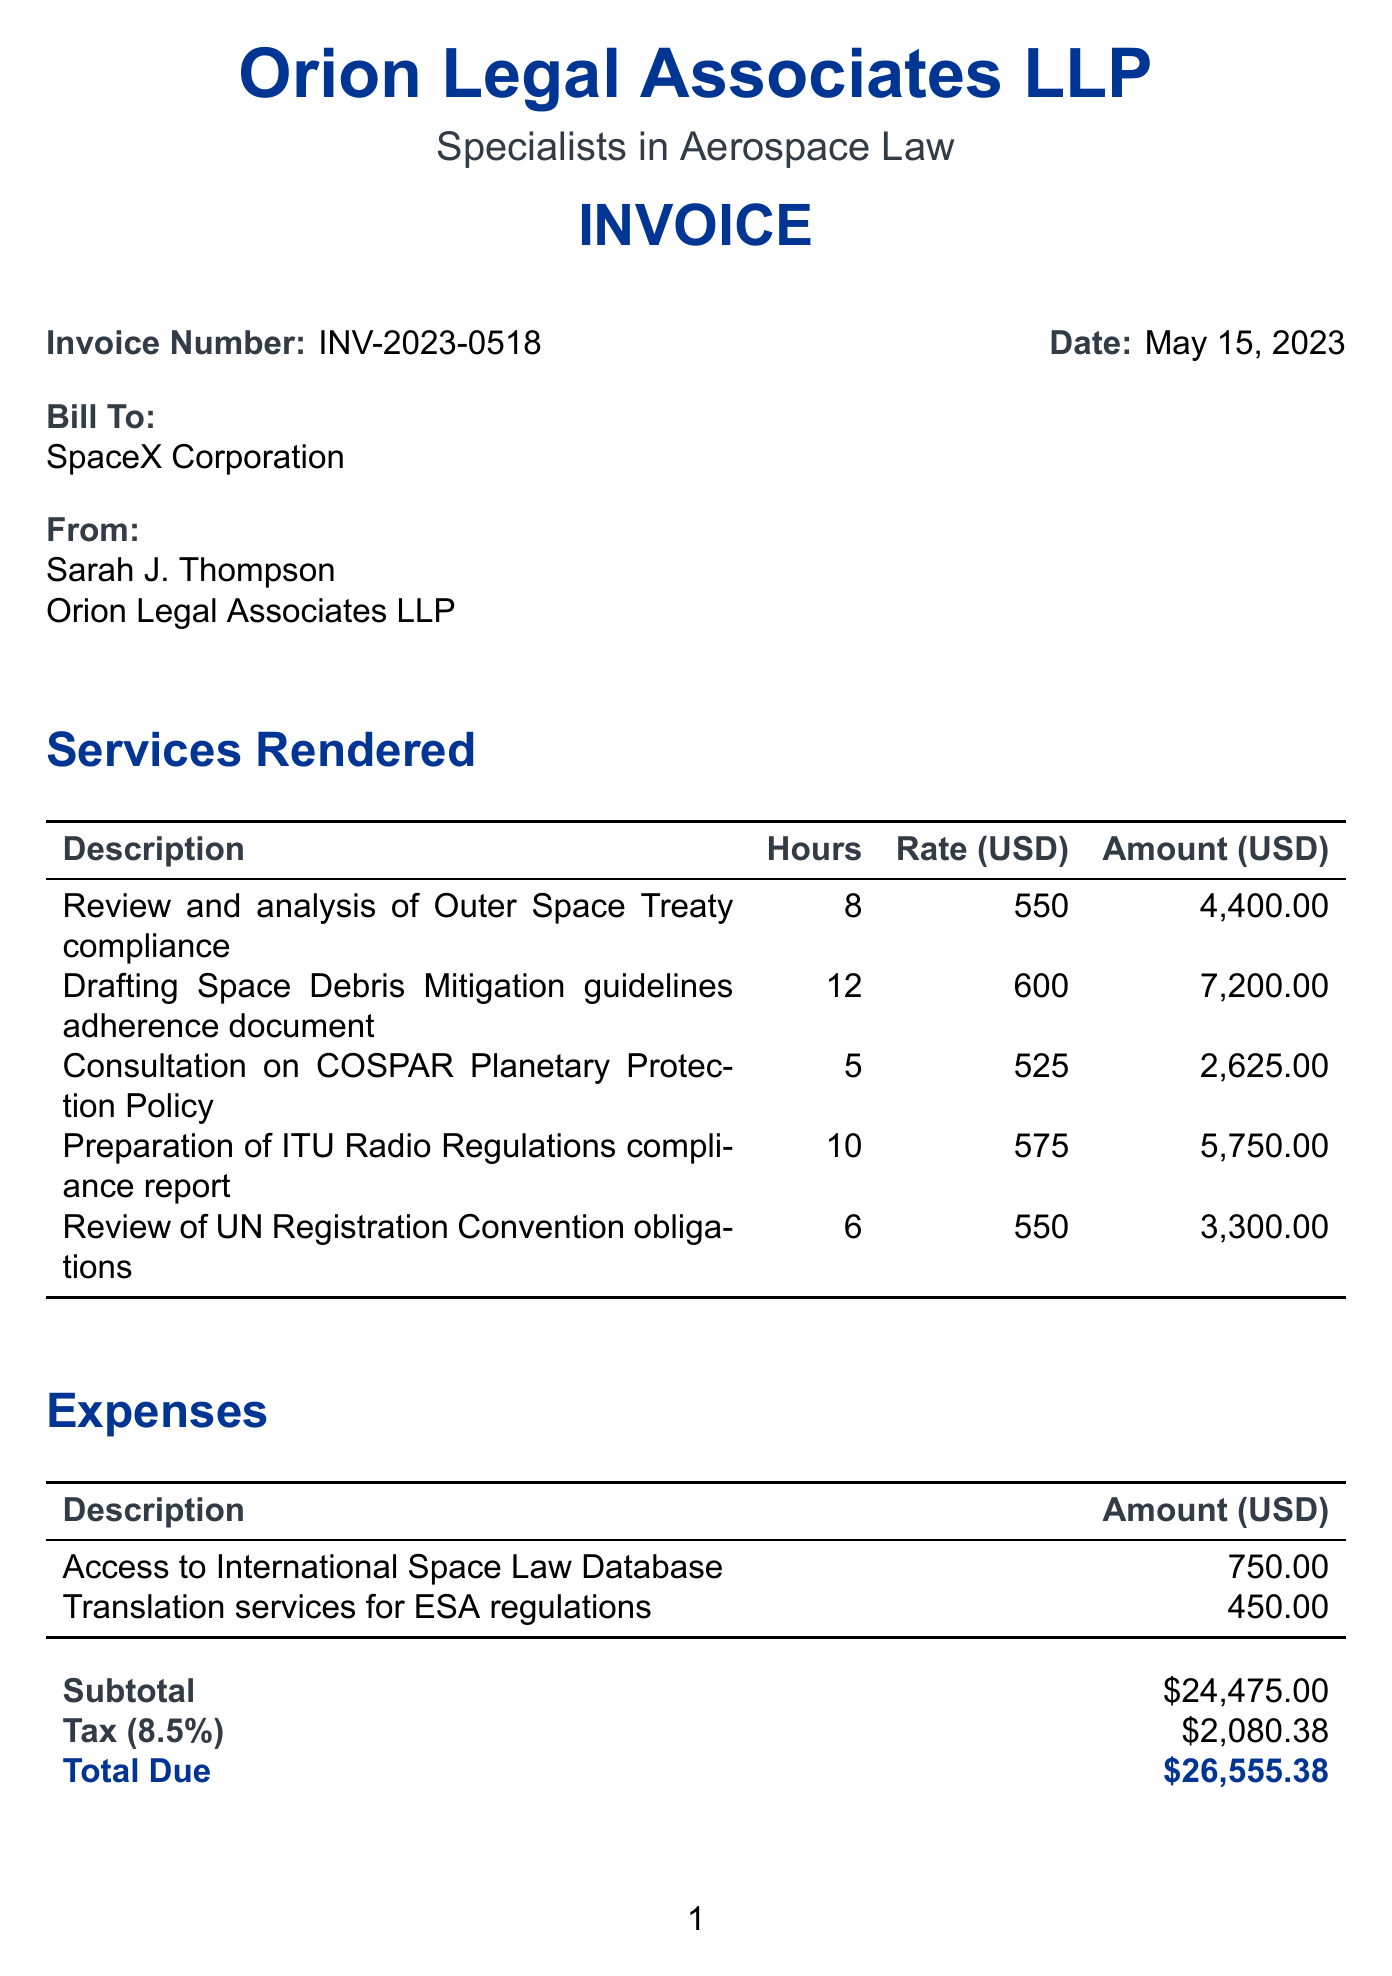What is the invoice number? The invoice number is prominently displayed in the document, indicating its unique identifier for tracking purposes.
Answer: INV-2023-0518 Who is the client? The client's name is mentioned at the beginning of the document in the billing section.
Answer: SpaceX Corporation What is the due date for the payment? The due date is specified in the payment terms section and indicates when the payment should be made.
Answer: Net 30 How many hours were spent on drafting Space Debris Mitigation guidelines? The document lists the hours spent for each service, detailing the specific time allocation for this task.
Answer: 12 What is the total amount due? The total amount due is calculated at the end of the invoice, summing up all services, taxes, and expenses.
Answer: $26,555.38 What is the tax rate applied to the invoice? The tax rate is outlined in the subtotal section of the document, detailing the percentage applied to the services rendered.
Answer: 8.5% How much was charged for reviewing Outer Space Treaty compliance? The document provides detailed amounts for each service rendered, highlighting the specific charge for this review.
Answer: $4,400.00 What is the late fee percentage per month? The late fee percentage is stated in the payment terms section of the document, indicating the financial penalty for late payments.
Answer: 1.5% 